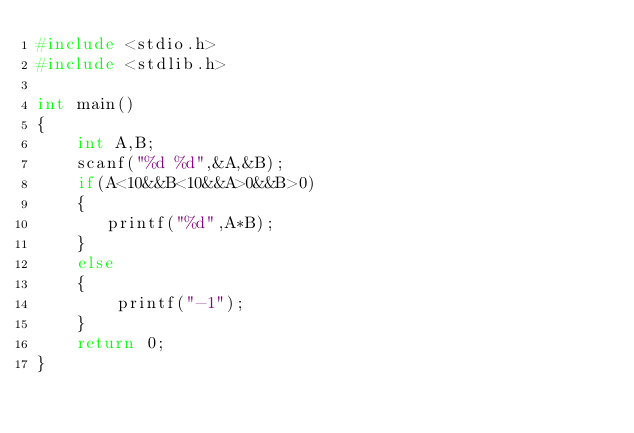<code> <loc_0><loc_0><loc_500><loc_500><_C_>#include <stdio.h>
#include <stdlib.h>

int main()
{
    int A,B;
    scanf("%d %d",&A,&B);
    if(A<10&&B<10&&A>0&&B>0)
    {
       printf("%d",A*B);
    }
    else
    {
        printf("-1");
    }
    return 0;
}
</code> 